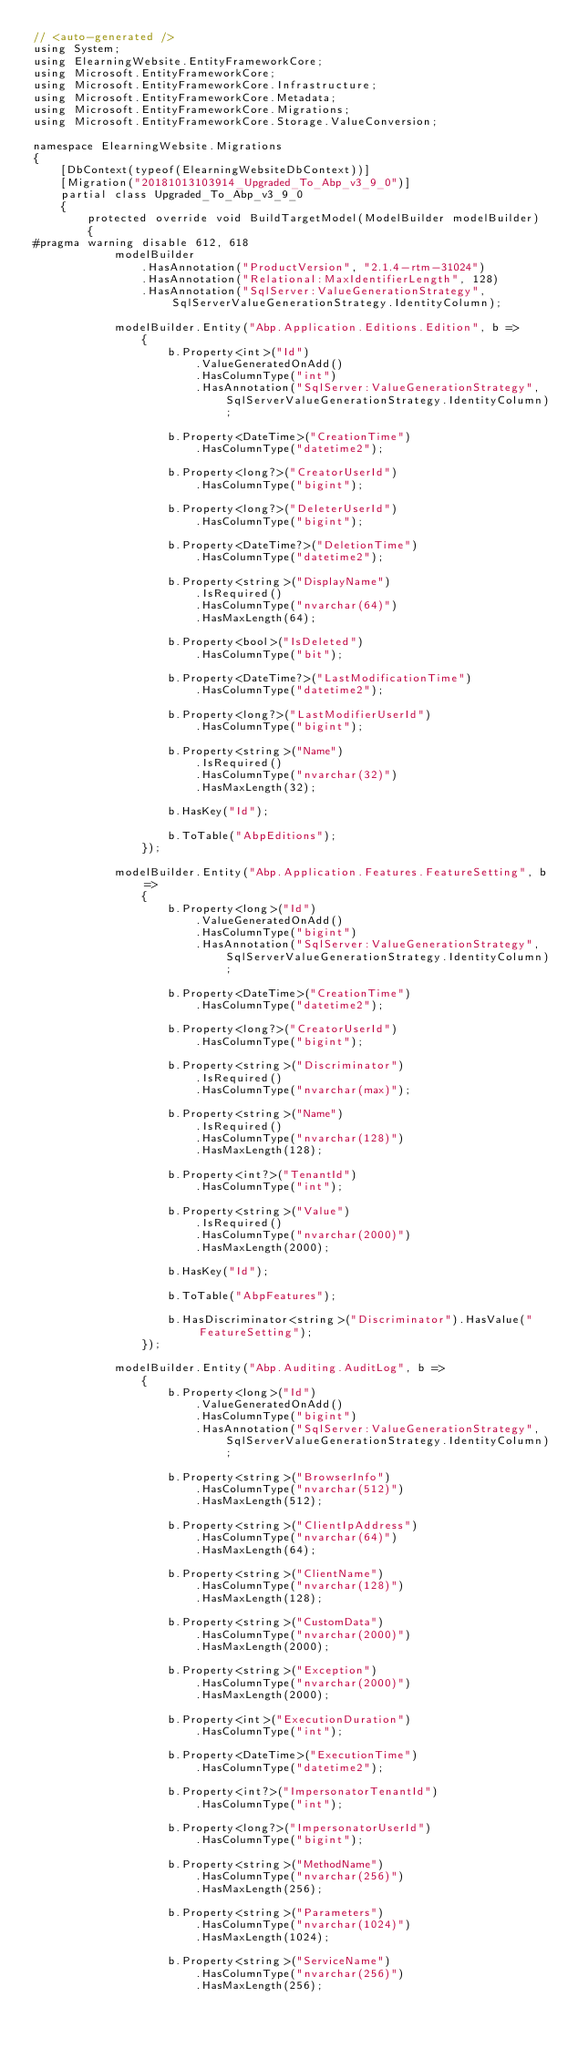<code> <loc_0><loc_0><loc_500><loc_500><_C#_>// <auto-generated />
using System;
using ElearningWebsite.EntityFrameworkCore;
using Microsoft.EntityFrameworkCore;
using Microsoft.EntityFrameworkCore.Infrastructure;
using Microsoft.EntityFrameworkCore.Metadata;
using Microsoft.EntityFrameworkCore.Migrations;
using Microsoft.EntityFrameworkCore.Storage.ValueConversion;

namespace ElearningWebsite.Migrations
{
    [DbContext(typeof(ElearningWebsiteDbContext))]
    [Migration("20181013103914_Upgraded_To_Abp_v3_9_0")]
    partial class Upgraded_To_Abp_v3_9_0
    {
        protected override void BuildTargetModel(ModelBuilder modelBuilder)
        {
#pragma warning disable 612, 618
            modelBuilder
                .HasAnnotation("ProductVersion", "2.1.4-rtm-31024")
                .HasAnnotation("Relational:MaxIdentifierLength", 128)
                .HasAnnotation("SqlServer:ValueGenerationStrategy", SqlServerValueGenerationStrategy.IdentityColumn);

            modelBuilder.Entity("Abp.Application.Editions.Edition", b =>
                {
                    b.Property<int>("Id")
                        .ValueGeneratedOnAdd()
                        .HasColumnType("int")
                        .HasAnnotation("SqlServer:ValueGenerationStrategy", SqlServerValueGenerationStrategy.IdentityColumn);

                    b.Property<DateTime>("CreationTime")
                        .HasColumnType("datetime2");

                    b.Property<long?>("CreatorUserId")
                        .HasColumnType("bigint");

                    b.Property<long?>("DeleterUserId")
                        .HasColumnType("bigint");

                    b.Property<DateTime?>("DeletionTime")
                        .HasColumnType("datetime2");

                    b.Property<string>("DisplayName")
                        .IsRequired()
                        .HasColumnType("nvarchar(64)")
                        .HasMaxLength(64);

                    b.Property<bool>("IsDeleted")
                        .HasColumnType("bit");

                    b.Property<DateTime?>("LastModificationTime")
                        .HasColumnType("datetime2");

                    b.Property<long?>("LastModifierUserId")
                        .HasColumnType("bigint");

                    b.Property<string>("Name")
                        .IsRequired()
                        .HasColumnType("nvarchar(32)")
                        .HasMaxLength(32);

                    b.HasKey("Id");

                    b.ToTable("AbpEditions");
                });

            modelBuilder.Entity("Abp.Application.Features.FeatureSetting", b =>
                {
                    b.Property<long>("Id")
                        .ValueGeneratedOnAdd()
                        .HasColumnType("bigint")
                        .HasAnnotation("SqlServer:ValueGenerationStrategy", SqlServerValueGenerationStrategy.IdentityColumn);

                    b.Property<DateTime>("CreationTime")
                        .HasColumnType("datetime2");

                    b.Property<long?>("CreatorUserId")
                        .HasColumnType("bigint");

                    b.Property<string>("Discriminator")
                        .IsRequired()
                        .HasColumnType("nvarchar(max)");

                    b.Property<string>("Name")
                        .IsRequired()
                        .HasColumnType("nvarchar(128)")
                        .HasMaxLength(128);

                    b.Property<int?>("TenantId")
                        .HasColumnType("int");

                    b.Property<string>("Value")
                        .IsRequired()
                        .HasColumnType("nvarchar(2000)")
                        .HasMaxLength(2000);

                    b.HasKey("Id");

                    b.ToTable("AbpFeatures");

                    b.HasDiscriminator<string>("Discriminator").HasValue("FeatureSetting");
                });

            modelBuilder.Entity("Abp.Auditing.AuditLog", b =>
                {
                    b.Property<long>("Id")
                        .ValueGeneratedOnAdd()
                        .HasColumnType("bigint")
                        .HasAnnotation("SqlServer:ValueGenerationStrategy", SqlServerValueGenerationStrategy.IdentityColumn);

                    b.Property<string>("BrowserInfo")
                        .HasColumnType("nvarchar(512)")
                        .HasMaxLength(512);

                    b.Property<string>("ClientIpAddress")
                        .HasColumnType("nvarchar(64)")
                        .HasMaxLength(64);

                    b.Property<string>("ClientName")
                        .HasColumnType("nvarchar(128)")
                        .HasMaxLength(128);

                    b.Property<string>("CustomData")
                        .HasColumnType("nvarchar(2000)")
                        .HasMaxLength(2000);

                    b.Property<string>("Exception")
                        .HasColumnType("nvarchar(2000)")
                        .HasMaxLength(2000);

                    b.Property<int>("ExecutionDuration")
                        .HasColumnType("int");

                    b.Property<DateTime>("ExecutionTime")
                        .HasColumnType("datetime2");

                    b.Property<int?>("ImpersonatorTenantId")
                        .HasColumnType("int");

                    b.Property<long?>("ImpersonatorUserId")
                        .HasColumnType("bigint");

                    b.Property<string>("MethodName")
                        .HasColumnType("nvarchar(256)")
                        .HasMaxLength(256);

                    b.Property<string>("Parameters")
                        .HasColumnType("nvarchar(1024)")
                        .HasMaxLength(1024);

                    b.Property<string>("ServiceName")
                        .HasColumnType("nvarchar(256)")
                        .HasMaxLength(256);
</code> 